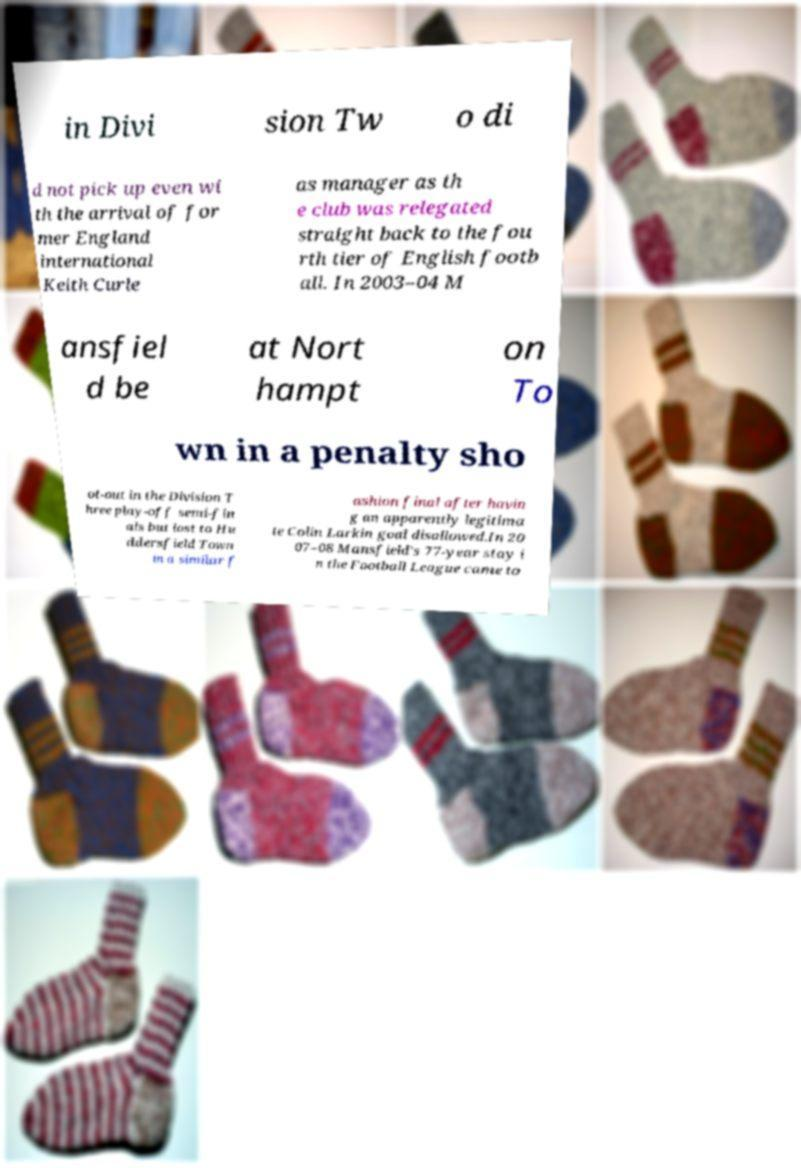What messages or text are displayed in this image? I need them in a readable, typed format. in Divi sion Tw o di d not pick up even wi th the arrival of for mer England international Keith Curle as manager as th e club was relegated straight back to the fou rth tier of English footb all. In 2003–04 M ansfiel d be at Nort hampt on To wn in a penalty sho ot-out in the Division T hree play-off semi-fin als but lost to Hu ddersfield Town in a similar f ashion final after havin g an apparently legitima te Colin Larkin goal disallowed.In 20 07–08 Mansfield's 77-year stay i n the Football League came to 